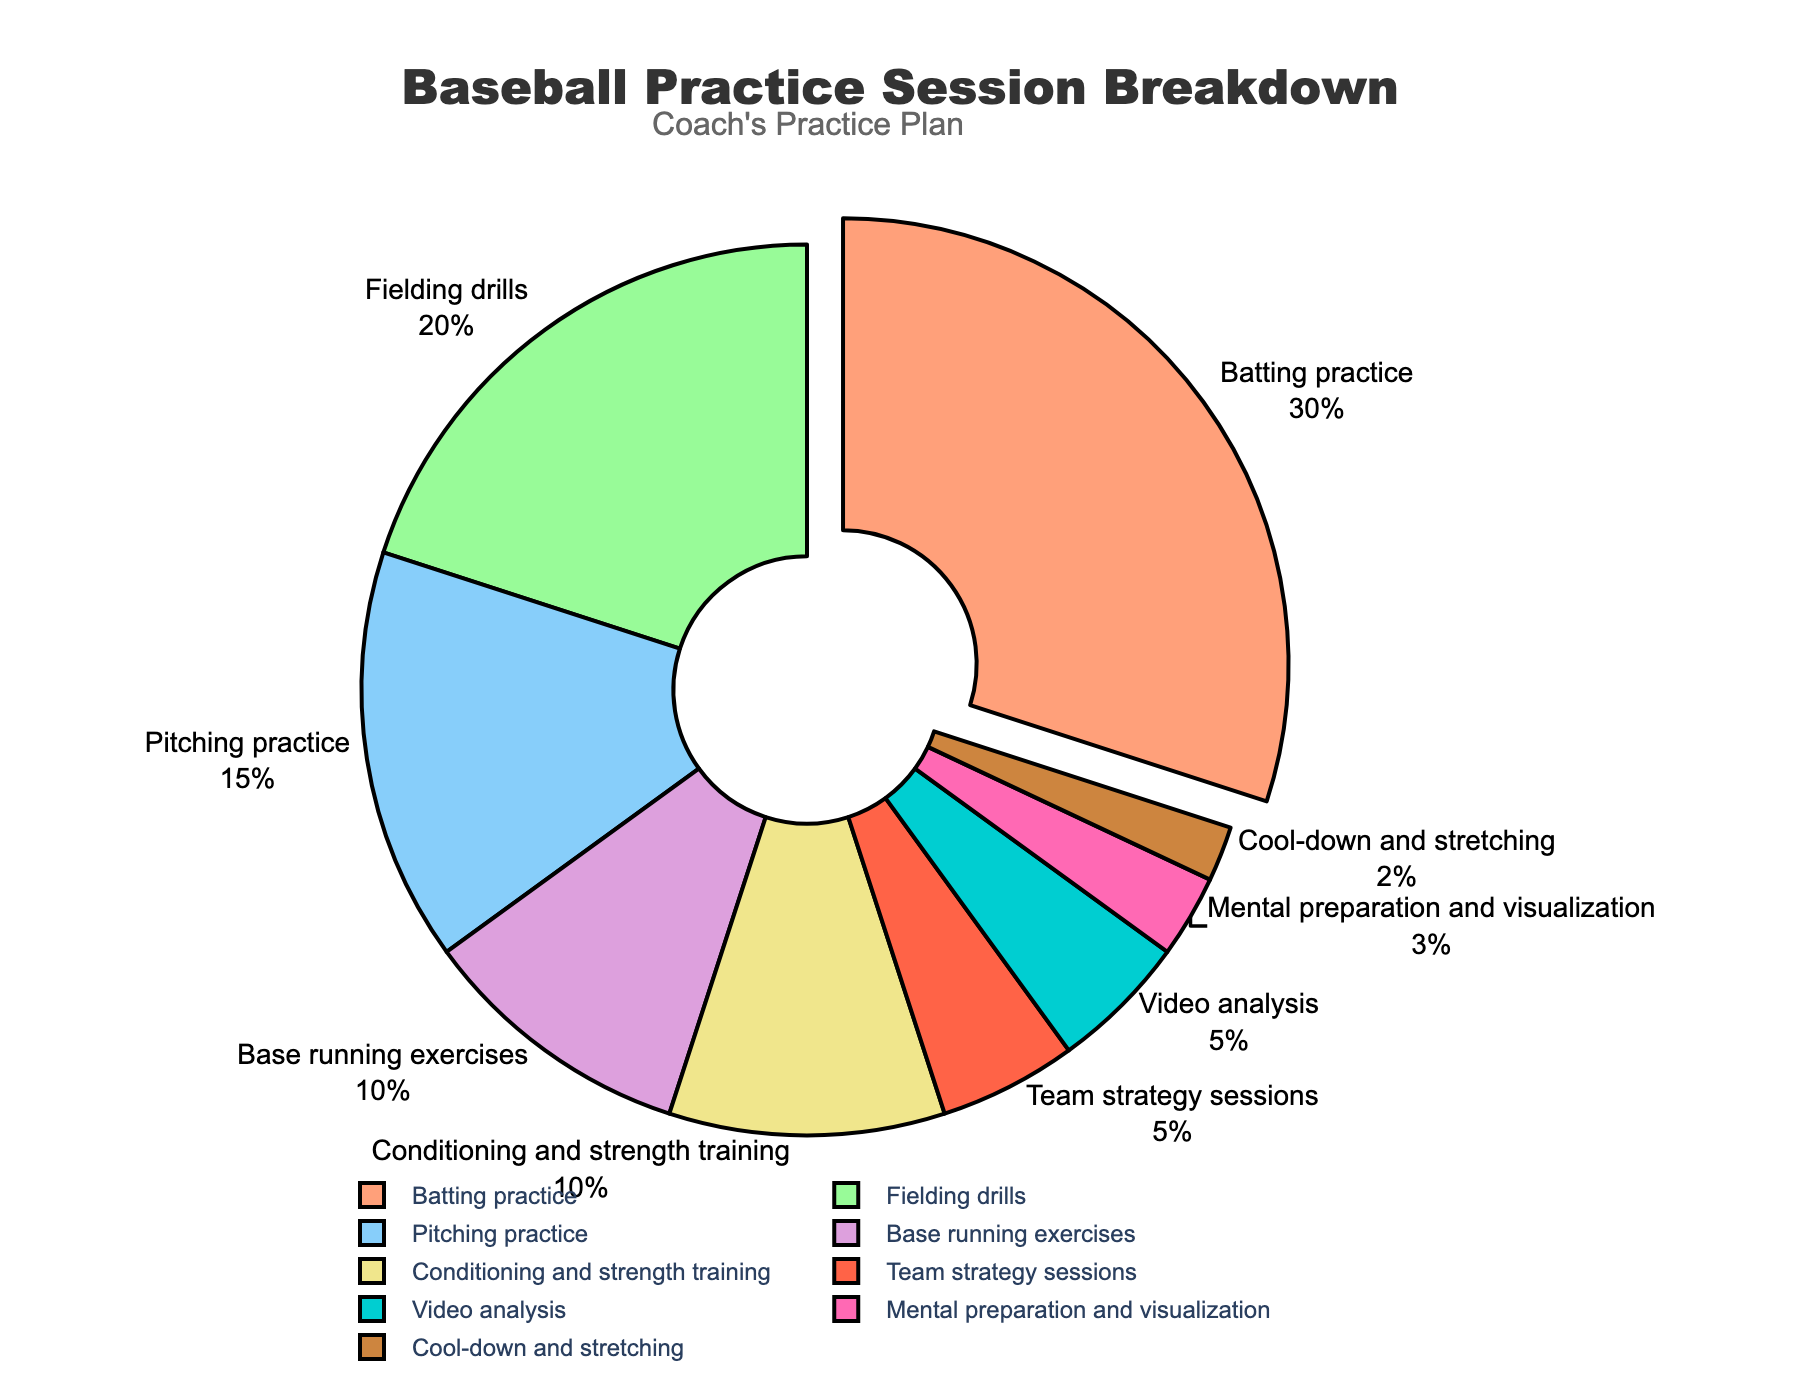What activity takes up the largest percentage of the practice session? The figure shows various activities with their respective percentages. The activity with the largest slice is batting practice at 30%.
Answer: Batting practice How does the combined percentage of fielding drills and pitching practice compare to that of batting practice? Fielding drills is 20% and pitching practice is 15%, making a combined total of 20 + 15 = 35%. Batting practice is 30%. Thus, the combined percentage of fielding drills and pitching practice (35%) is greater than batting practice (30%).
Answer: 35% > 30% Which activities collectively take up exactly half of the practice session? We need to find activities that sum up to 50%. Batting practice (30%) and fielding drills (20%) add up to 30 + 20 = 50%. These two activities together take up exactly half of the practice session.
Answer: Batting practice and fielding drills What is the difference in percentage between the smallest and the largest activity? The largest activity is batting practice at 30% and the smallest is cool-down and stretching at 2%. The difference is 30 - 2 = 28%.
Answer: 28% Which activities have the same percentage, and what is that percentage? Video analysis and team strategy sessions each have a slice indicating 5%. These two activities have the same percentage.
Answer: Video analysis and team strategy sessions, 5% How much more time is spent on base running exercises than on cool-down and stretching? Base running exercises are 10%, and cool-down and stretching is 2%. The difference is 10% - 2% = 8%.
Answer: 8% What percentage of the practice session is dedicated to activities related to physical conditioning and strength? Conditioning and strength training is 10%, and cool-down and stretching is 2%. Summing these gives 10% + 2% = 12%.
Answer: 12% If mental preparation and visualization were increased by 2%, what would the new total percentage for these activities and video analysis be? Mental preparation and visualization is currently 3%. Increasing it by 2% makes it 3% + 2% = 5%. Video analysis is already 5%. The combined new total for mental preparation and visualization plus video analysis would be 5% + 5% = 10%.
Answer: 10% How much more time is spent on conditioning and strength training compared to mental preparation and visualization? Conditioning and strength training is 10%, and mental preparation and visualization is 3%. The difference is 10% - 3% = 7%.
Answer: 7% What is the average percentage of time spent on activities under 10%? The activities under 10% are base running exercises (10%), conditioning and strength training (10%), team strategy sessions (5%), video analysis (5%), mental preparation and visualization (3%), and cool-down and stretching (2%). Adding these gives 10 + 10 + 5 + 5 + 3 + 2 = 35%. There are 6 activities, so the average is 35% / 6 ≈ 5.83%.
Answer: 5.83% 